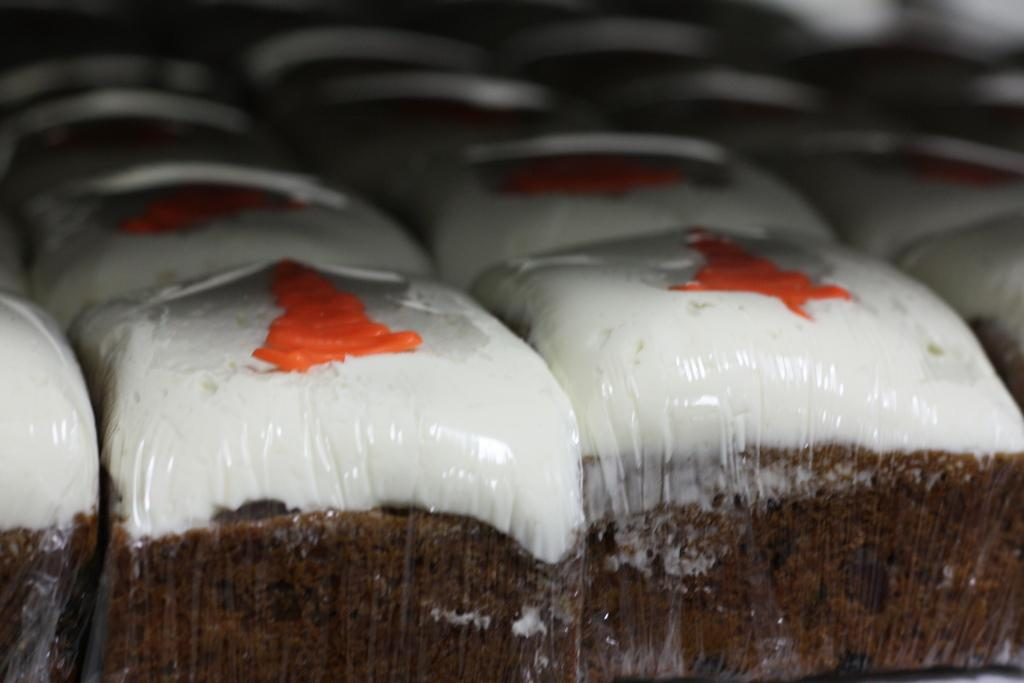What type of food items can be seen in the image? There are cakes in the image. How are the cakes presented in the image? The cakes are packed and arranged in rows. What type of bells can be heard ringing in the image? There are no bells present in the image, and therefore no sounds can be heard. 